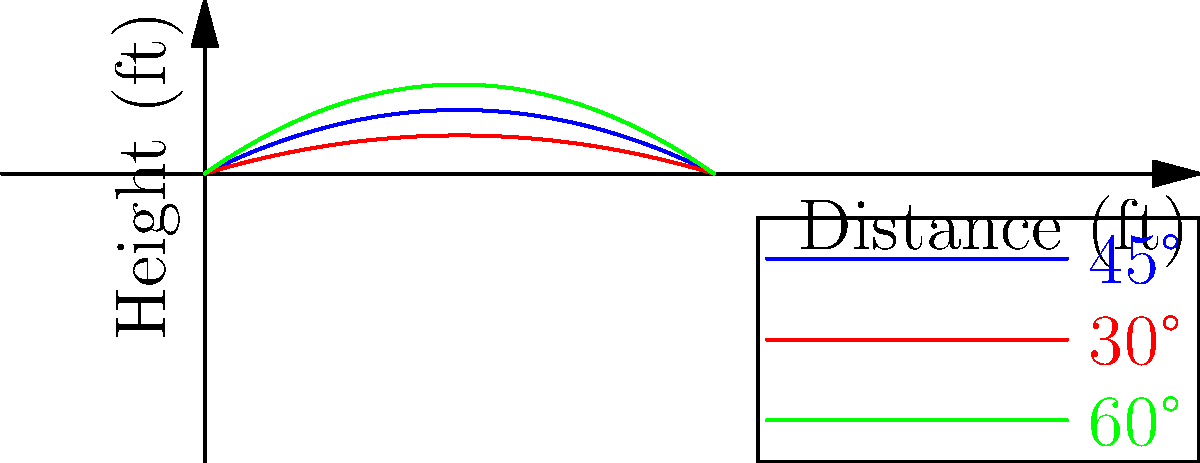As the operations manager, you're analyzing pitch trajectories to optimize team strategy. The graph shows the trajectories of a baseball pitched at three different angles: 30°, 45°, and 60°. Assuming the same initial velocity for all pitches, which angle results in the greatest horizontal distance traveled by the ball before it reaches the ground? To determine which angle results in the greatest horizontal distance, we need to analyze the trajectories shown in the graph:

1. The blue curve represents the 45° pitch
2. The red curve represents the 30° pitch
3. The green curve represents the 60° pitch

Step 1: Observe the x-intercepts (where the curves meet the x-axis)
- The x-intercept represents the horizontal distance traveled before the ball reaches the ground.

Step 2: Compare the x-intercepts
- The blue curve (45°) extends furthest along the x-axis before reaching zero height.
- The red curve (30°) has a lower maximum height but doesn't travel as far horizontally.
- The green curve (60°) reaches the greatest height but falls short of the 45° pitch horizontally.

Step 3: Apply physics principles
- In an ideal scenario, a 45° angle maximizes the horizontal distance for a projectile.
- This is because it provides an optimal balance between vertical and horizontal velocity components.

Step 4: Consider real-world factors
- Air resistance and spin can affect the trajectory, but the 45° angle generally remains optimal for maximum distance.

Therefore, the 45° pitch (blue curve) results in the greatest horizontal distance traveled by the ball before it reaches the ground.
Answer: 45° 